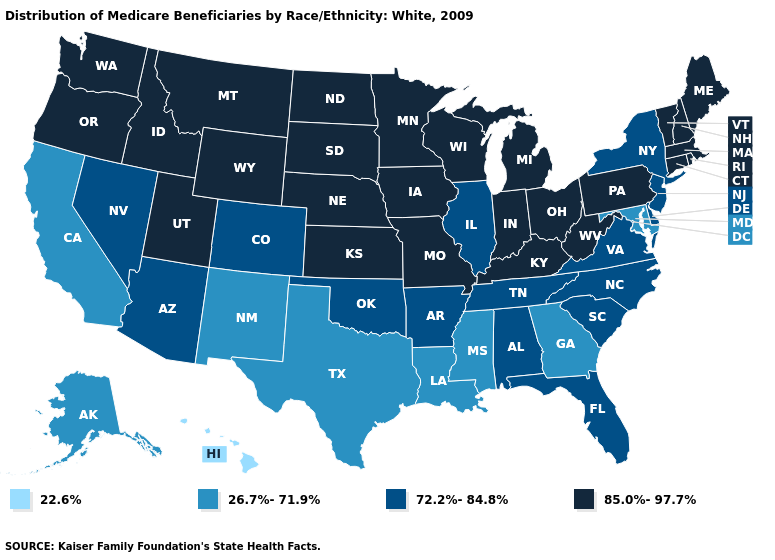What is the value of Florida?
Quick response, please. 72.2%-84.8%. Does Rhode Island have a higher value than New Mexico?
Concise answer only. Yes. Does Nebraska have the highest value in the USA?
Quick response, please. Yes. Does South Dakota have a lower value than New Mexico?
Keep it brief. No. Does Minnesota have the same value as Alaska?
Keep it brief. No. What is the value of Maryland?
Short answer required. 26.7%-71.9%. Which states have the highest value in the USA?
Answer briefly. Connecticut, Idaho, Indiana, Iowa, Kansas, Kentucky, Maine, Massachusetts, Michigan, Minnesota, Missouri, Montana, Nebraska, New Hampshire, North Dakota, Ohio, Oregon, Pennsylvania, Rhode Island, South Dakota, Utah, Vermont, Washington, West Virginia, Wisconsin, Wyoming. What is the value of Virginia?
Quick response, please. 72.2%-84.8%. Does Tennessee have the same value as Iowa?
Keep it brief. No. Name the states that have a value in the range 26.7%-71.9%?
Be succinct. Alaska, California, Georgia, Louisiana, Maryland, Mississippi, New Mexico, Texas. What is the lowest value in states that border Washington?
Short answer required. 85.0%-97.7%. Among the states that border Nebraska , which have the highest value?
Be succinct. Iowa, Kansas, Missouri, South Dakota, Wyoming. What is the value of South Carolina?
Keep it brief. 72.2%-84.8%. What is the value of Ohio?
Quick response, please. 85.0%-97.7%. What is the value of Utah?
Answer briefly. 85.0%-97.7%. 